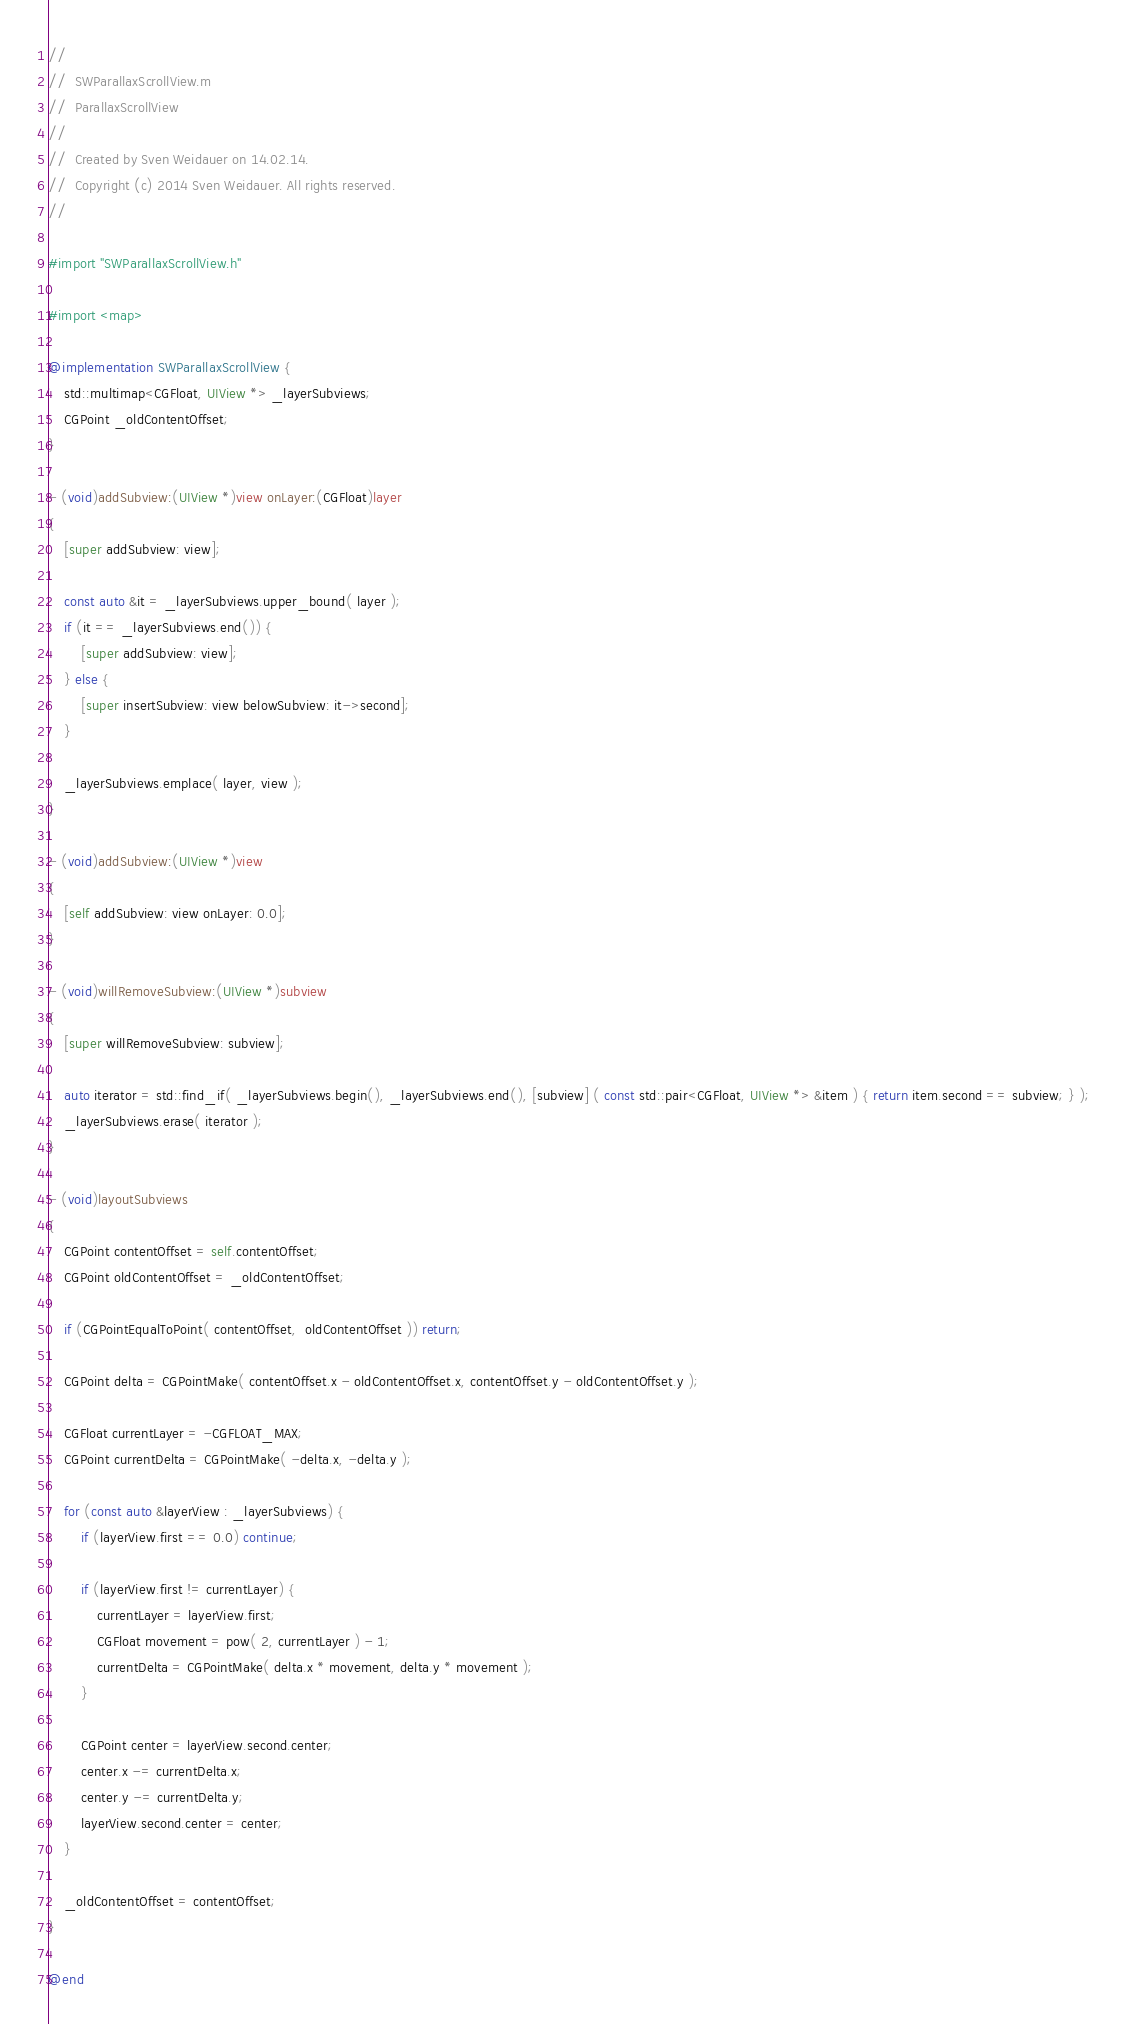<code> <loc_0><loc_0><loc_500><loc_500><_ObjectiveC_>//
//  SWParallaxScrollView.m
//  ParallaxScrollView
//
//  Created by Sven Weidauer on 14.02.14.
//  Copyright (c) 2014 Sven Weidauer. All rights reserved.
//

#import "SWParallaxScrollView.h"

#import <map>

@implementation SWParallaxScrollView {
    std::multimap<CGFloat, UIView *> _layerSubviews;
    CGPoint _oldContentOffset;
}

- (void)addSubview:(UIView *)view onLayer:(CGFloat)layer
{
    [super addSubview: view];

    const auto &it = _layerSubviews.upper_bound( layer );
    if (it == _layerSubviews.end()) {
        [super addSubview: view];
    } else {
        [super insertSubview: view belowSubview: it->second];
    }

    _layerSubviews.emplace( layer, view );
}

- (void)addSubview:(UIView *)view
{
    [self addSubview: view onLayer: 0.0];
}

- (void)willRemoveSubview:(UIView *)subview
{
    [super willRemoveSubview: subview];

    auto iterator = std::find_if( _layerSubviews.begin(), _layerSubviews.end(), [subview] ( const std::pair<CGFloat, UIView *> &item ) { return item.second == subview; } );
    _layerSubviews.erase( iterator );
}

- (void)layoutSubviews
{
    CGPoint contentOffset = self.contentOffset;
    CGPoint oldContentOffset = _oldContentOffset;

    if (CGPointEqualToPoint( contentOffset,  oldContentOffset )) return;

    CGPoint delta = CGPointMake( contentOffset.x - oldContentOffset.x, contentOffset.y - oldContentOffset.y );

    CGFloat currentLayer = -CGFLOAT_MAX;
    CGPoint currentDelta = CGPointMake( -delta.x, -delta.y );

    for (const auto &layerView : _layerSubviews) {
        if (layerView.first == 0.0) continue;

        if (layerView.first != currentLayer) {
            currentLayer = layerView.first;
            CGFloat movement = pow( 2, currentLayer ) - 1;
            currentDelta = CGPointMake( delta.x * movement, delta.y * movement );
        }

        CGPoint center = layerView.second.center;
        center.x -= currentDelta.x;
        center.y -= currentDelta.y;
        layerView.second.center = center;
    }

    _oldContentOffset = contentOffset;
}

@end
</code> 